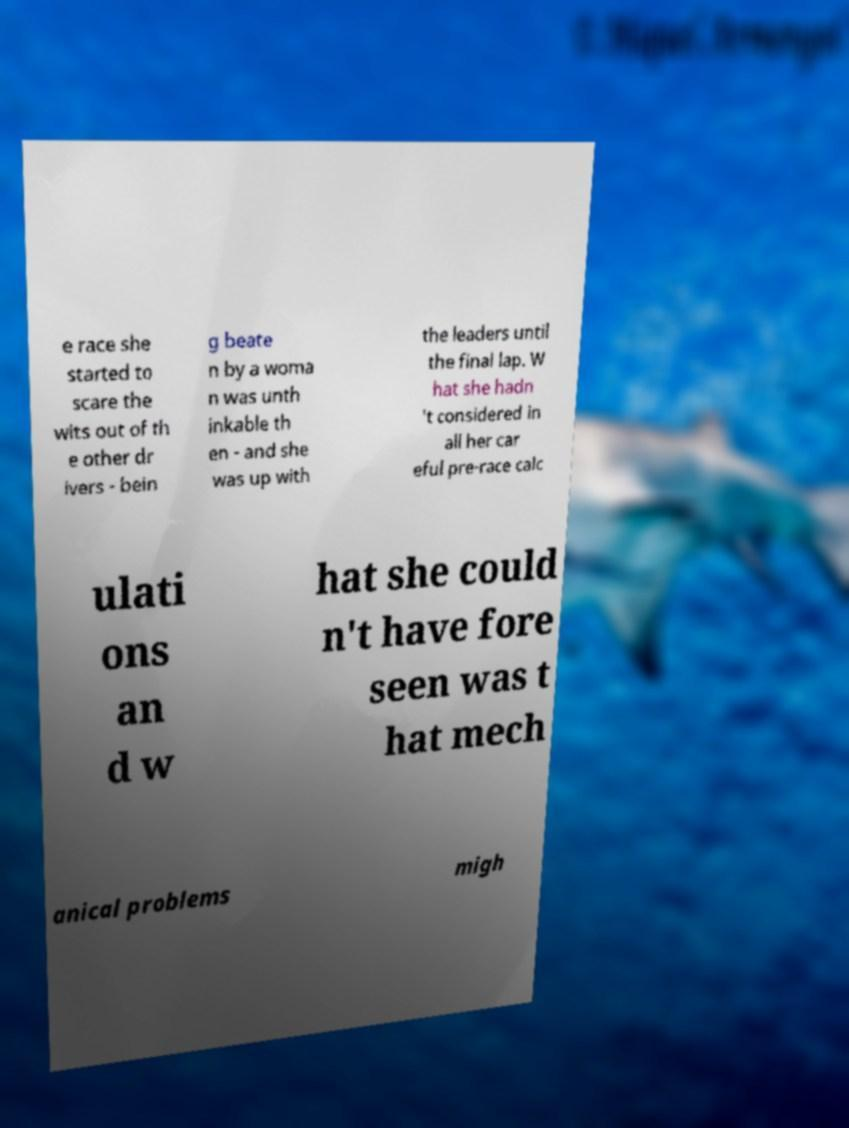What messages or text are displayed in this image? I need them in a readable, typed format. e race she started to scare the wits out of th e other dr ivers - bein g beate n by a woma n was unth inkable th en - and she was up with the leaders until the final lap. W hat she hadn 't considered in all her car eful pre-race calc ulati ons an d w hat she could n't have fore seen was t hat mech anical problems migh 